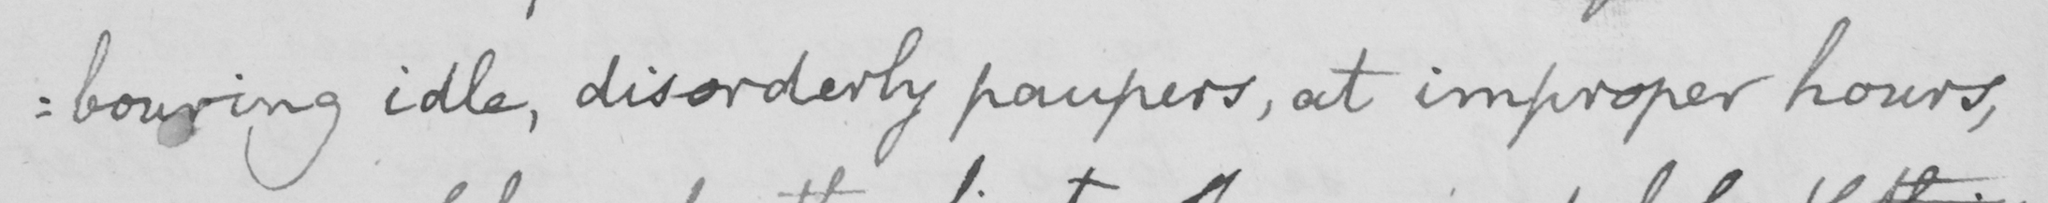What does this handwritten line say? : bouring idle , disorderly paupers , at improper hours , 